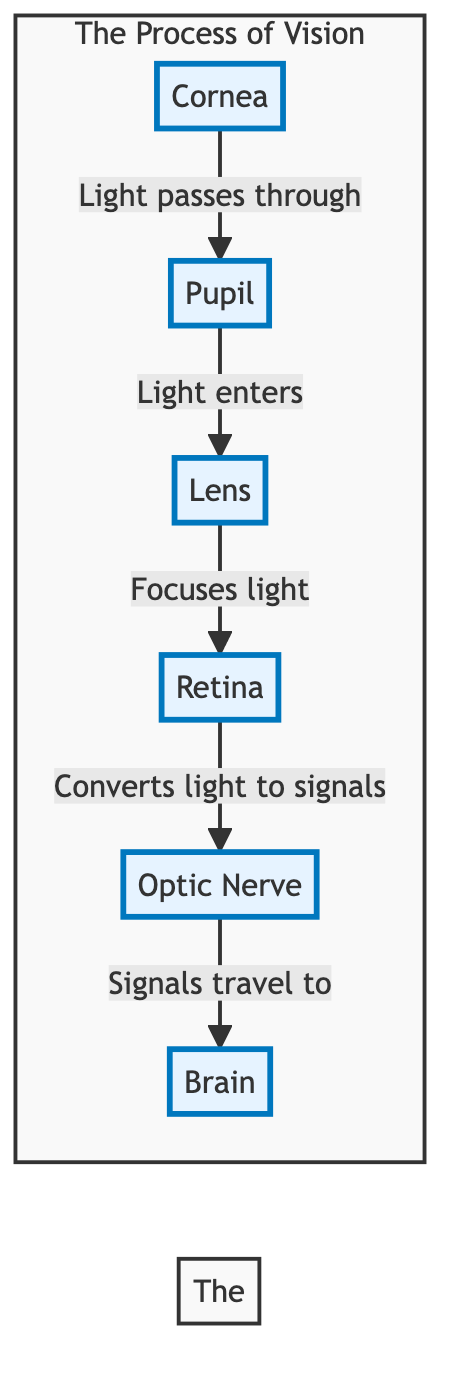What is the first part of the eye light passes through? According to the diagram, the first part of the eye that light encounters is the cornea, which is labeled at the beginning of the flow.
Answer: Cornea What does the pupil do? The diagram indicates that the pupil serves as an entrance for light, allowing it to travel into the lens after it passes through.
Answer: Light enters How many components are depicted in the process of vision? By counting the components in the diagram, there are six key parts that are highlighted in the process of vision: cornea, pupil, lens, retina, optic nerve, and brain.
Answer: Six What is the role of the lens in the diagram? The diagram states that the lens focuses light onto the retina, indicating that its function is to refine the light for clearer imaging on the retina.
Answer: Focuses light What happens at the retina? The diagram specifies that the retina converts light into signals, which is a crucial step in processing visual information before it is sent to the optic nerve.
Answer: Converts light to signals How does the process progress from the retina? After the retina converts light to signals, these signals travel to the brain via the optic nerve, indicating a direct relationship between the conversion of light and communication to the brain.
Answer: Signals travel to brain Which structure sends signals to the brain? The optic nerve is identified in the diagram as the structure that carries the signals from the retina to the brain, allowing for visual information processing.
Answer: Optic Nerve What sequence describes how light travels through the eye? The sequence of how light travels through the eye as per the diagram is: cornea → pupil → lens → retina → optic nerve → brain, outlining the journey light takes through these structures.
Answer: Cornea → Pupil → Lens → Retina → Optic Nerve → Brain What type of diagram is used here? The diagram is identified as a flowchart, which effectively illustrates the sequential process of vision by mapping out the components involved and their connections.
Answer: Flowchart 